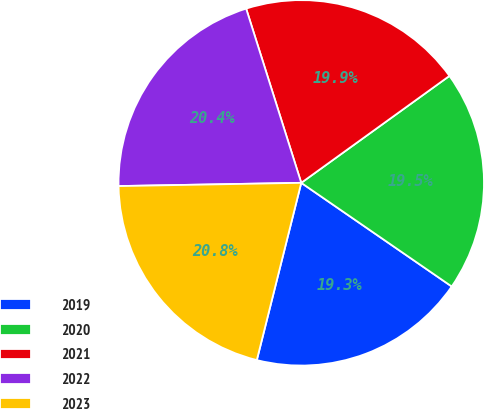Convert chart to OTSL. <chart><loc_0><loc_0><loc_500><loc_500><pie_chart><fcel>2019<fcel>2020<fcel>2021<fcel>2022<fcel>2023<nl><fcel>19.31%<fcel>19.55%<fcel>19.93%<fcel>20.41%<fcel>20.81%<nl></chart> 